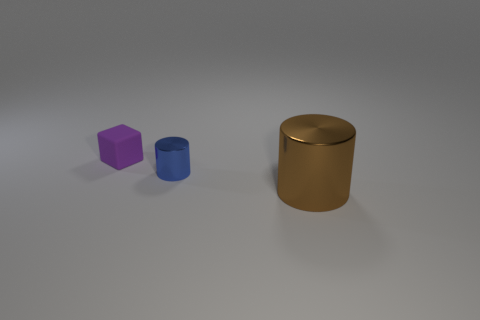Are there any matte cubes of the same size as the purple matte thing? No, there are no cubes that match the size of the purple matte object in the image. The purple object appears to be a matte cube, and the only other objects present are a smaller blue cylinder and a larger gold cylinder, none of which are cube-shaped or match its size. 